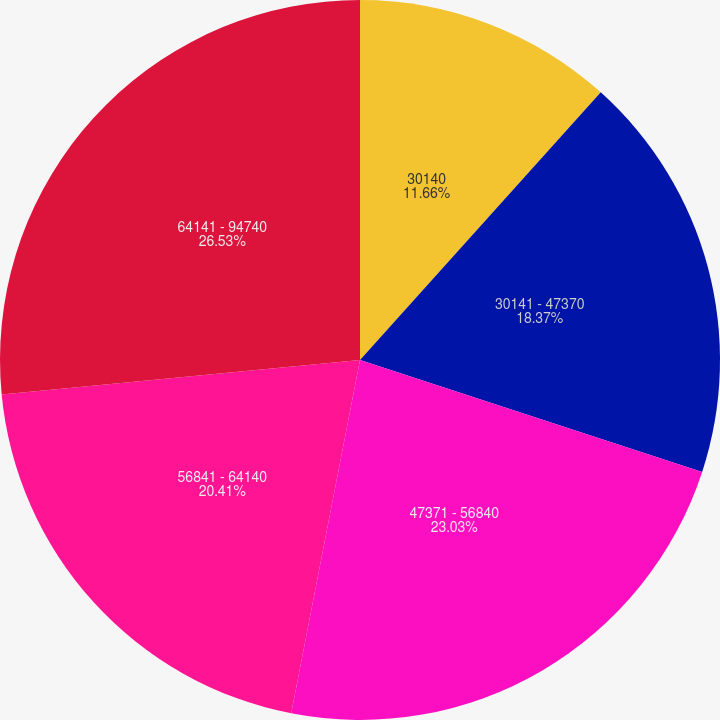Convert chart. <chart><loc_0><loc_0><loc_500><loc_500><pie_chart><fcel>30140<fcel>30141 - 47370<fcel>47371 - 56840<fcel>56841 - 64140<fcel>64141 - 94740<nl><fcel>11.66%<fcel>18.37%<fcel>23.03%<fcel>20.41%<fcel>26.53%<nl></chart> 